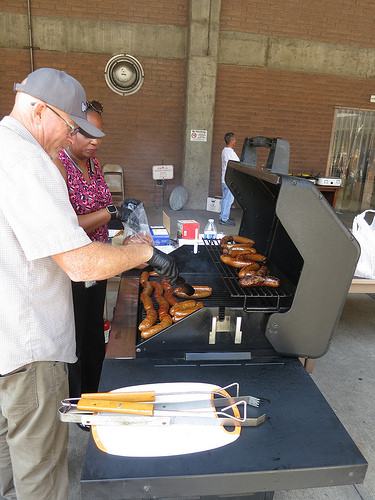<image>
Is the tongs to the right of the grill? Yes. From this viewpoint, the tongs is positioned to the right side relative to the grill. Where is the man in relation to the woman? Is it next to the woman? Yes. The man is positioned adjacent to the woman, located nearby in the same general area. 